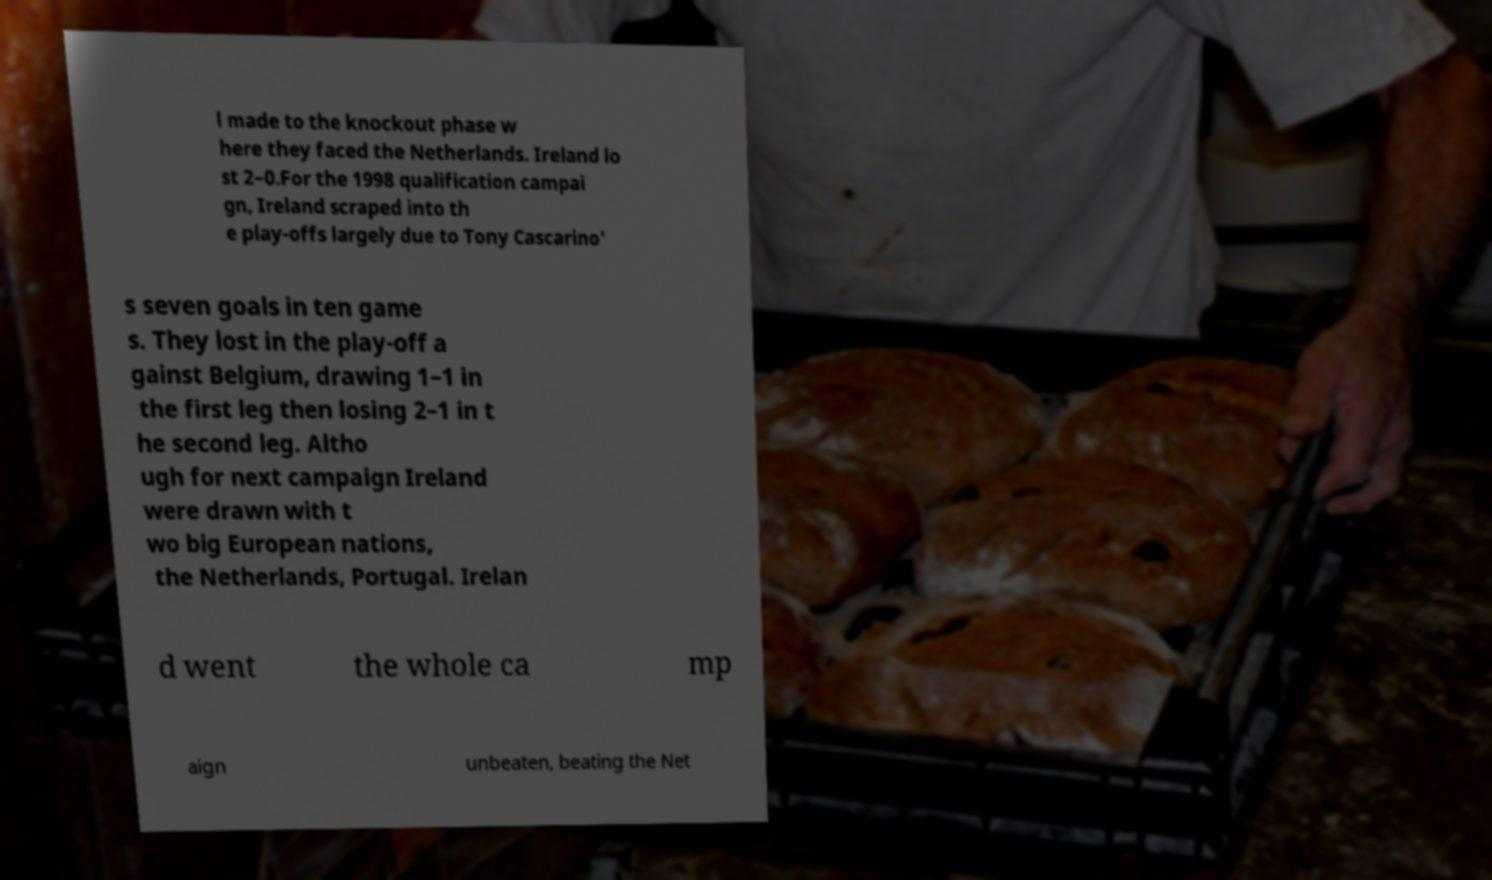Can you read and provide the text displayed in the image?This photo seems to have some interesting text. Can you extract and type it out for me? l made to the knockout phase w here they faced the Netherlands. Ireland lo st 2–0.For the 1998 qualification campai gn, Ireland scraped into th e play-offs largely due to Tony Cascarino' s seven goals in ten game s. They lost in the play-off a gainst Belgium, drawing 1–1 in the first leg then losing 2–1 in t he second leg. Altho ugh for next campaign Ireland were drawn with t wo big European nations, the Netherlands, Portugal. Irelan d went the whole ca mp aign unbeaten, beating the Net 